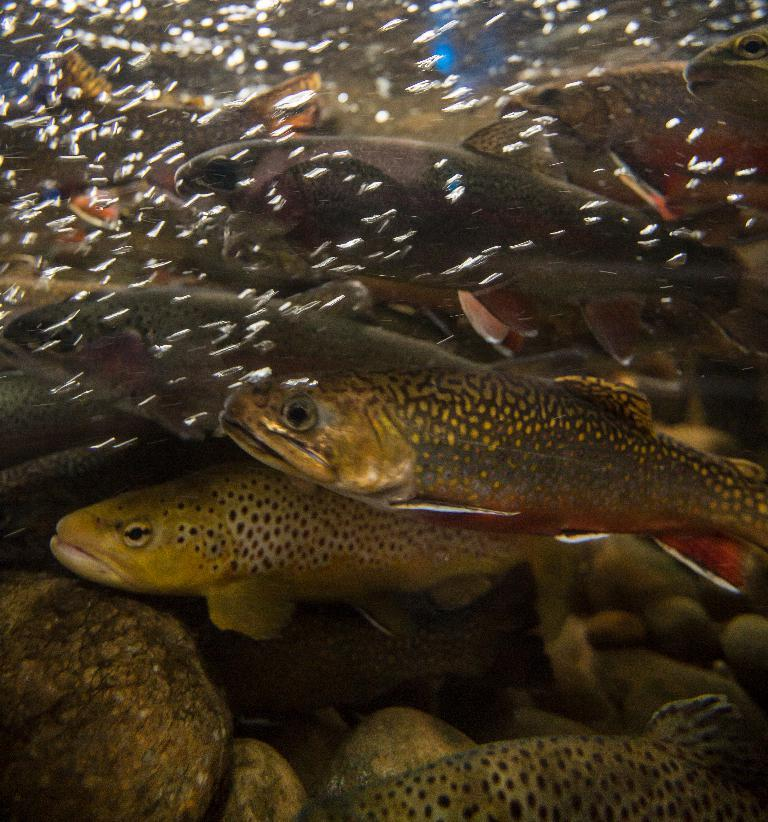What type of animals can be seen in the image? There are fish in the image. What other objects are present in the image? There are stones in the image. Where are the fish and stones located? The fish and stones are under the water. What is the value of the word "fish" in the image? There is no word "fish" present in the image, so it is not possible to determine its value. 